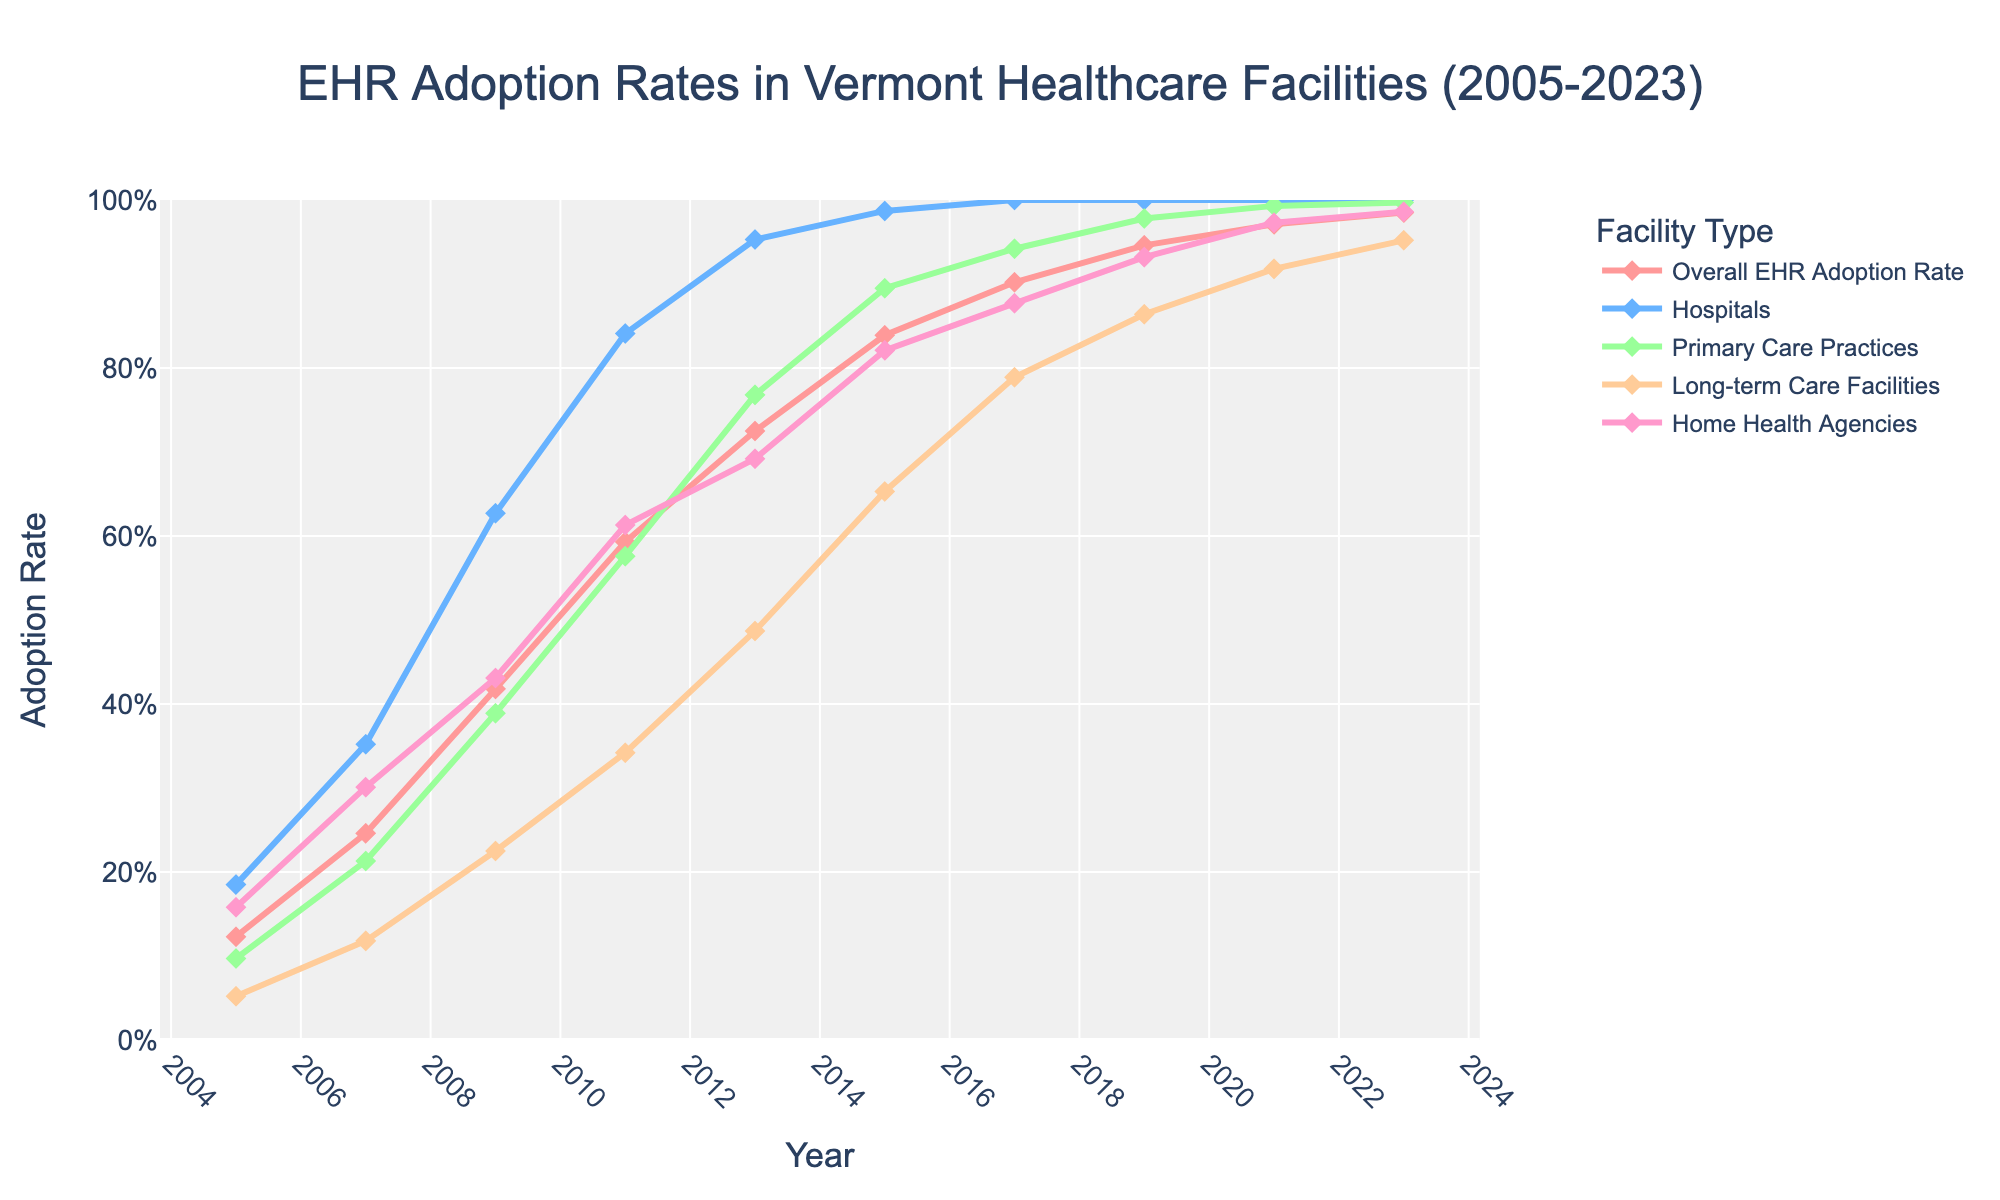What year did hospitals reach 100% EHR adoption rate? Look at the hospital adoption rate line, which is one of the lines in the chart. Identify the year where the line reaches 100%.
Answer: 2017 In 2009, which type of healthcare facility had the lowest EHR adoption rate? Refer to the lines for each facility type in 2009. Compare the heights of the markers to find the lowest one.
Answer: Long-term Care Facilities By how much did the overall EHR adoption rate increase from 2005 to 2011? Check the overall EHR adoption rate lines at 2005 and 2011, find the percentages, and calculate the difference: 59.3% - 12.3%.
Answer: 47% Which facility type saw the greatest increase in EHR adoption rate from 2009 to 2013? Calculate the difference in adoption rates for each facility from 2009 to 2013 and compare these values.
Answer: Primary Care Practices In 2021, how much higher was the EHR adoption rate in hospitals compared to long-term care facilities? Look at the EHR adoption rates for hospitals and long-term care facilities in 2021 and subtract the latter from the former: 100% - 91.8%.
Answer: 8.2% Which facility type consistently had the highest EHR adoption rates throughout the given period? Track the different lines across the entire timeline from 2005 to 2023. Identify which line (facility type) maintains the highest percentage values consistently.
Answer: Hospitals What was the percentage increase in EHR adoption for Home Health Agencies between 2007 and 2019? Calculate the difference between the adoption rates in 2019 (93.2%) and 2007 (30.1%), then find the percentage increase: [(93.2 - 30.1) / 30.1] * 100.
Answer: 209.63% By what percentage did EHR adoption rates in Primary Care Practices grow from 2015 to 2023? Subtract the rate in 2015 (89.5%) from the rate in 2023 (99.7%) and calculate the percentage increase: (99.7 - 89.5).
Answer: 10.2% Which facility type had the most gradual increase in EHR adoption rate from 2005 to 2023? Observe the slopes of the various facility lines over time to identify the one with the most gradual increase.
Answer: Long-term Care Facilities Comparing 2007 and 2019, which facility type had the greater rate of increase in EHR adoption rate, Hospitals or Home Health Agencies? Calculate the difference for Hospitals (100% - 35.2%) and Home Health Agencies (93.2% - 30.1%). Compare the two differences: 64.8% for Hospitals and 63.1% for Home Health Agencies.
Answer: Hospitals 